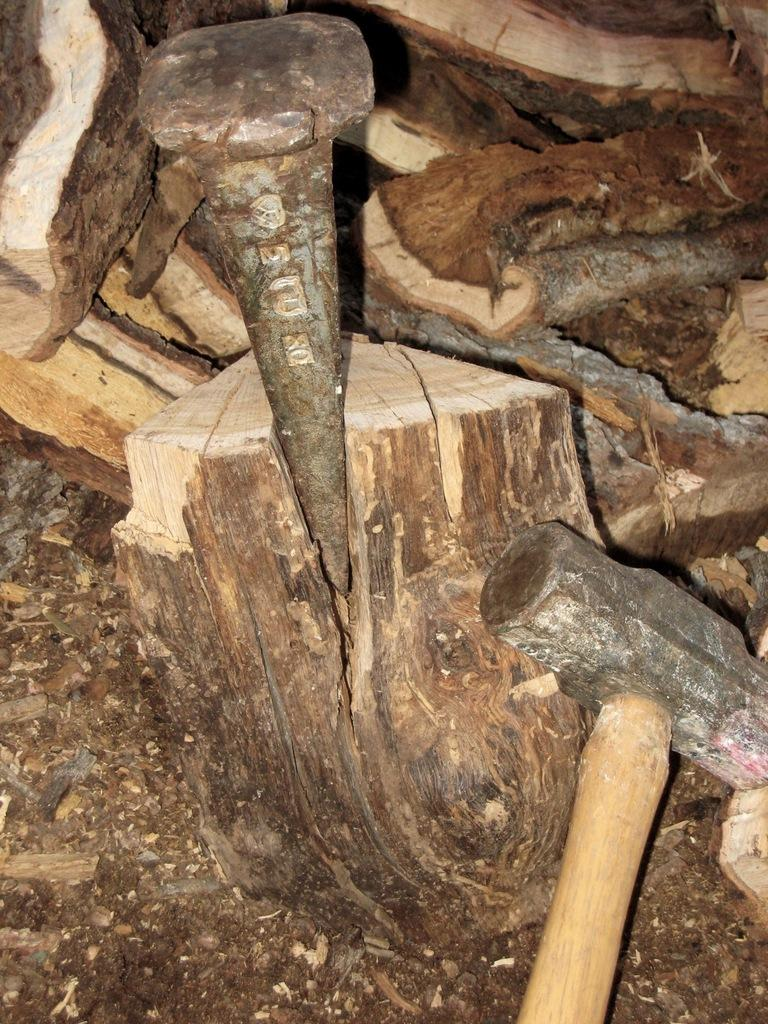What material is present in the image? There is wood in the image. What tool is visible in the image? There is a hammer in the image. How is the hammer positioned in the image? The hammer is truncated towards the bottom of the image. What object is used for fastening in the image? There is a nail in the image. How does the twig affect the wood during the rainstorm in the image? There is no twig or rainstorm present in the image; it only features wood, a hammer, and a nail. What type of stem is growing from the nail in the image? There is no stem growing from the nail in the image; it only features wood, a hammer, and a nail. 